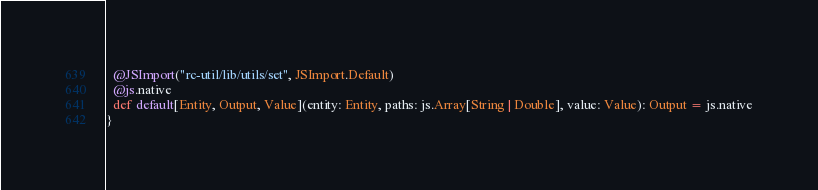<code> <loc_0><loc_0><loc_500><loc_500><_Scala_>  @JSImport("rc-util/lib/utils/set", JSImport.Default)
  @js.native
  def default[Entity, Output, Value](entity: Entity, paths: js.Array[String | Double], value: Value): Output = js.native
}
</code> 